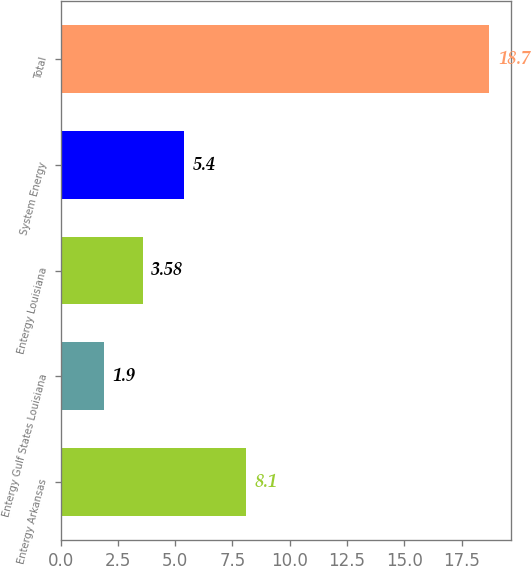Convert chart to OTSL. <chart><loc_0><loc_0><loc_500><loc_500><bar_chart><fcel>Entergy Arkansas<fcel>Entergy Gulf States Louisiana<fcel>Entergy Louisiana<fcel>System Energy<fcel>Total<nl><fcel>8.1<fcel>1.9<fcel>3.58<fcel>5.4<fcel>18.7<nl></chart> 